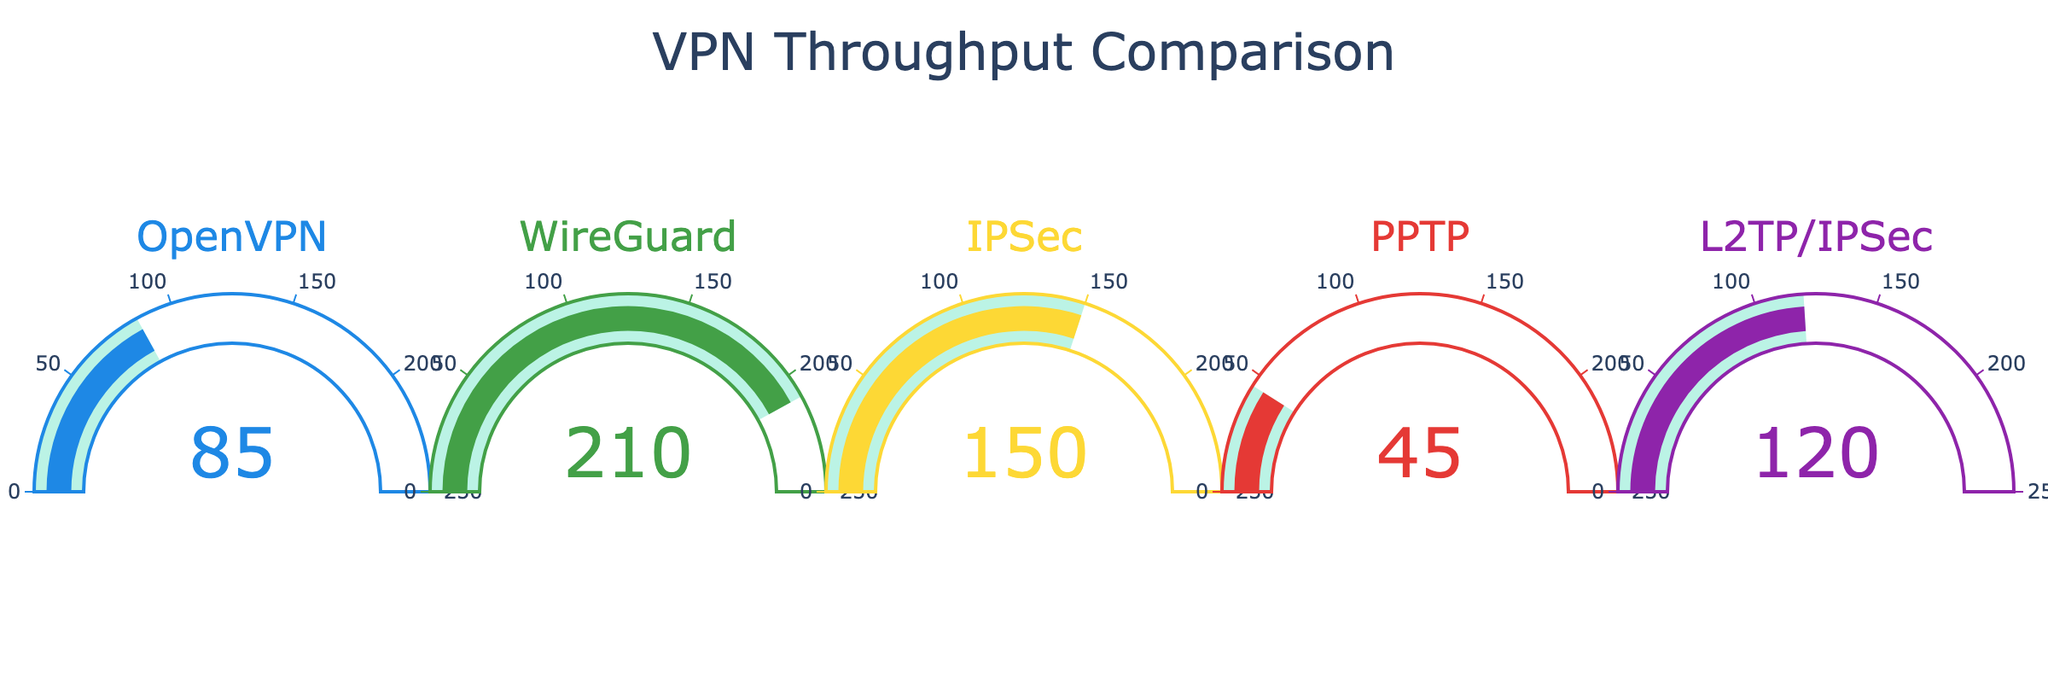How many VPN protocols are displayed in the gauge chart? Count the number of different VPN protocols listed on the gauges in the chart.
Answer: 5 Which VPN protocol has the highest throughput in Mbps? Compare the numbers on each gauge to find the highest throughput value. WireGuard is displayed with 210 Mbps.
Answer: WireGuard What's the difference in throughput between WireGuard and OpenVPN? Subtract the throughput of OpenVPN (85 Mbps) from WireGuard (210 Mbps). 210 - 85 = 125 Mbps.
Answer: 125 Mbps What is the average throughput of all the VPN protocols illustrated? Calculate the average by summing all the throughputs (85 + 210 + 150 + 45 + 120) and dividing by the number of protocols. Total = 610 Mbps, and there are 5 protocols. So, 610 / 5 = 122 Mbps.
Answer: 122 Mbps Which VPN protocol has the lowest throughput? Identify the lowest number displayed on the gauges, which corresponds to PPTP at 45 Mbps.
Answer: PPTP What's the aggregate throughput of IPSec and L2TP/IPSec? Add the throughput values of IPSec (150 Mbps) and L2TP/IPSec (120 Mbps). 150 + 120 = 270 Mbps.
Answer: 270 Mbps Are there any VPN protocols with throughput greater than 125 Mbps but less than 200 Mbps? Check the displayed throughputs and see if any are between 125 and 200 Mbps. In this case, IPSec is 150 Mbps.
Answer: IPSec What's the throughput range shown on the chart? The minimum value is 45 Mbps (PPTP) and the maximum value is 210 Mbps (WireGuard). Therefore, the range is from 45 to 210 Mbps.
Answer: 45-210 Mbps How much higher is WireGuard's throughput compared to the combined throughput of PPTP and OpenVPN? Calculate the sum of PPTP and OpenVPN (45 + 85 = 130 Mbps), then subtract from WireGuard (210 Mbps). 210 - 130 = 80 Mbps.
Answer: 80 Mbps 